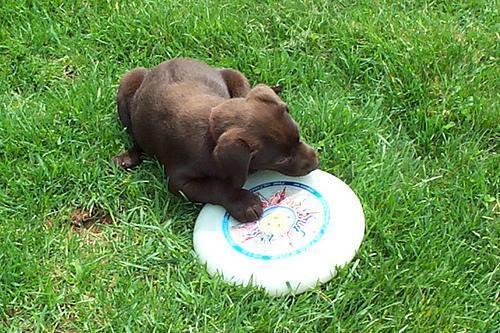How many people are wearing a helmet?
Give a very brief answer. 0. 